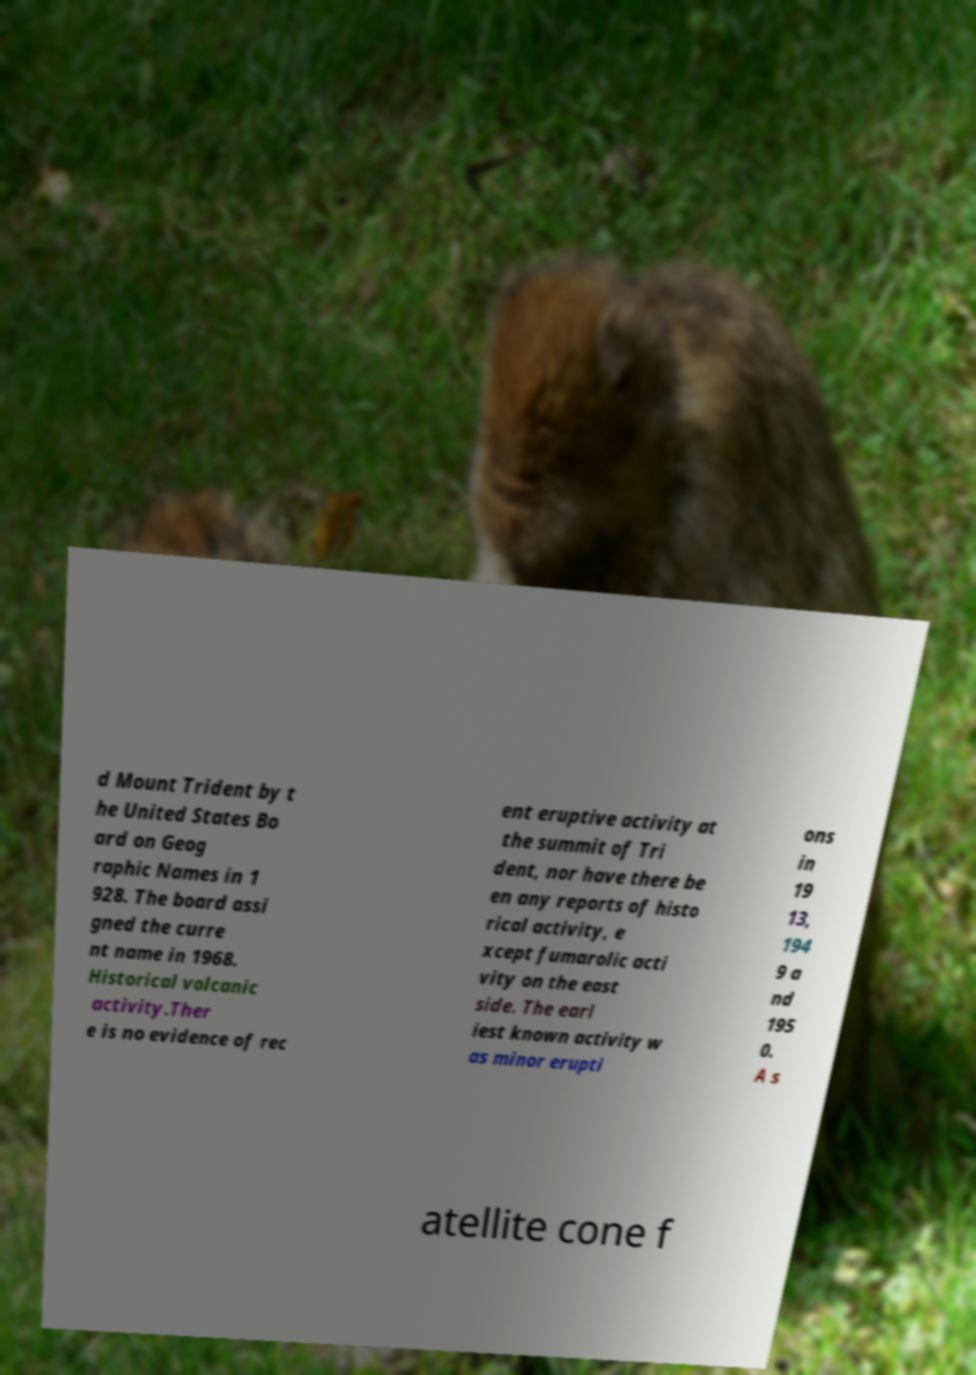Could you extract and type out the text from this image? d Mount Trident by t he United States Bo ard on Geog raphic Names in 1 928. The board assi gned the curre nt name in 1968. Historical volcanic activity.Ther e is no evidence of rec ent eruptive activity at the summit of Tri dent, nor have there be en any reports of histo rical activity, e xcept fumarolic acti vity on the east side. The earl iest known activity w as minor erupti ons in 19 13, 194 9 a nd 195 0. A s atellite cone f 